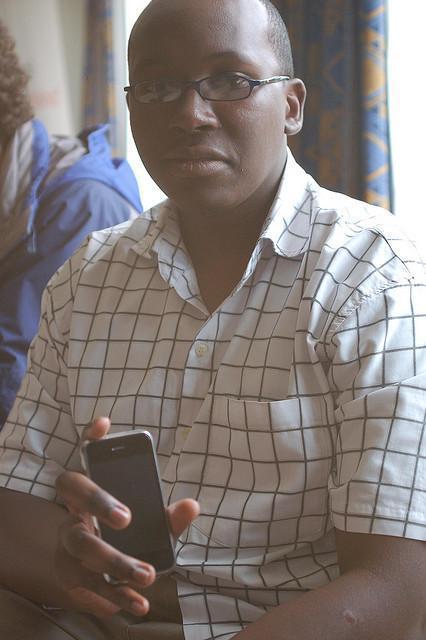How many people are in the picture?
Give a very brief answer. 2. 